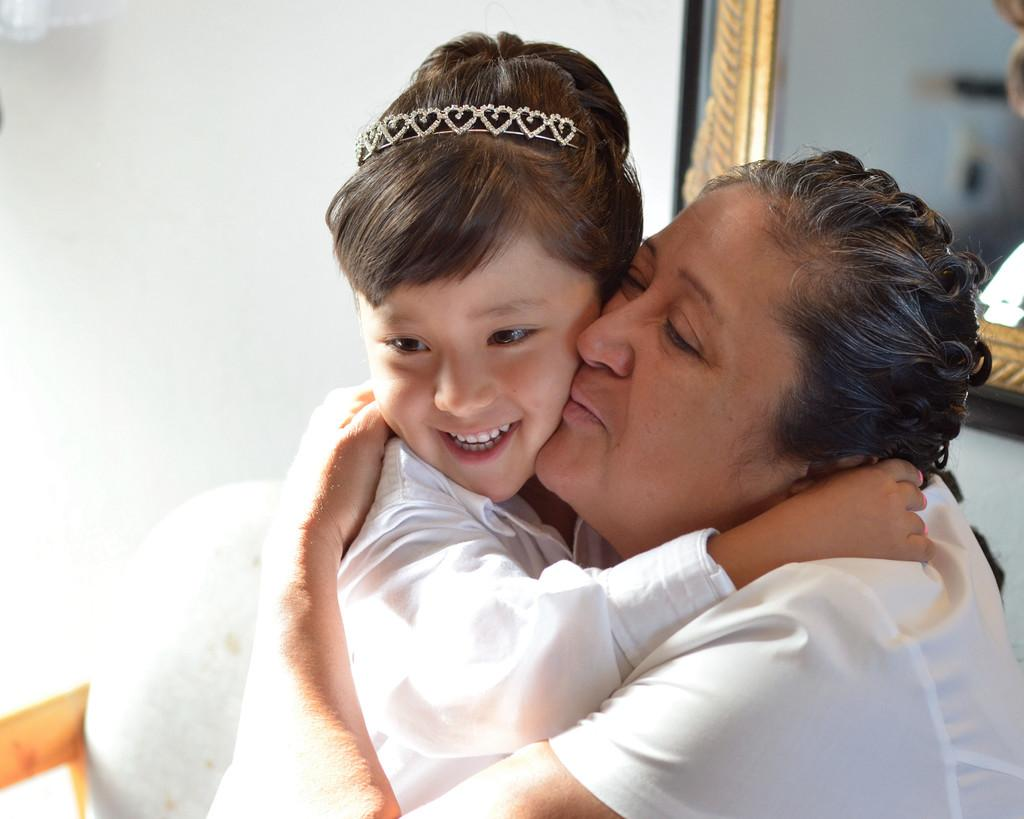Who is the main subject in the image? There is a lady in the image. What is the lady doing in the image? The lady is holding a kid. What can be seen in the background of the image? There is a frame on the wall in the background of the image. What type of smell can be detected in the image? There is no information about any smell in the image, so it cannot be determined from the picture. 